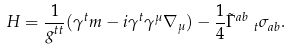Convert formula to latex. <formula><loc_0><loc_0><loc_500><loc_500>H = \frac { 1 } { g ^ { t t } } ( \gamma ^ { t } m - i \gamma ^ { t } \gamma ^ { \mu } \nabla _ { \mu } ) - \frac { 1 } { 4 } \tilde { \Gamma } ^ { a b } _ { \ \ t } \sigma _ { a b } .</formula> 